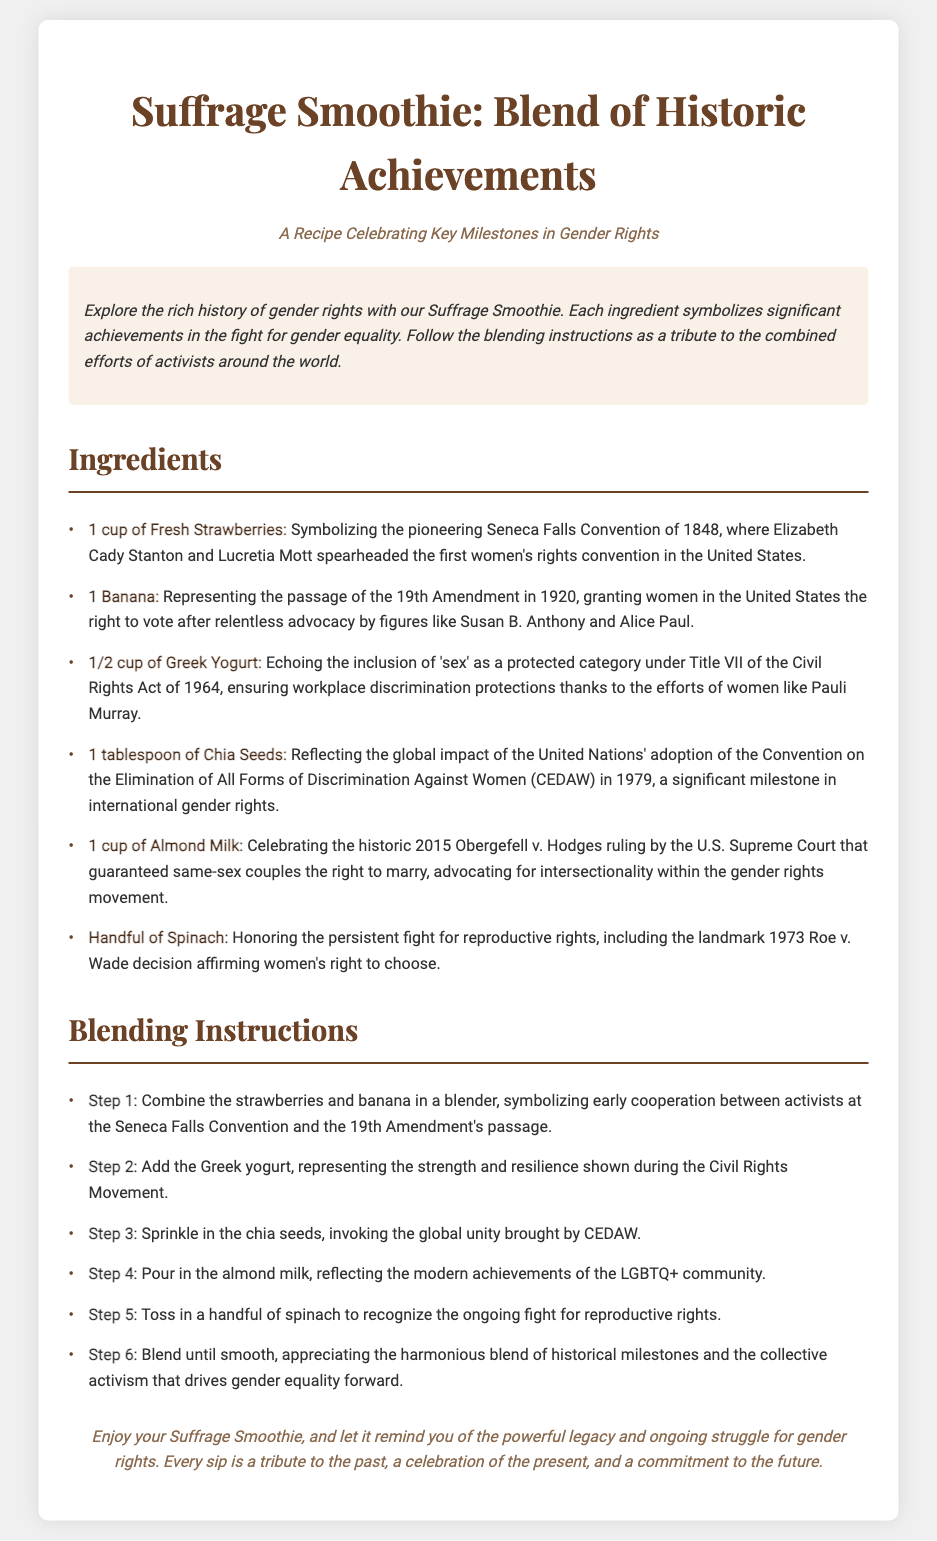What is the main title of the recipe? The main title is prominently displayed at the top of the document, which is "Suffrage Smoothie: Blend of Historic Achievements."
Answer: Suffrage Smoothie: Blend of Historic Achievements How many ingredients are listed in the recipe? The ingredients section details a total of six unique ingredients used in the recipe.
Answer: 6 What does the banana represent in the Suffrage Smoothie? The document indicates that the banana represents the passage of the 19th Amendment in 1920, granting women the right to vote.
Answer: The passage of the 19th Amendment Which year marks the Seneca Falls Convention mentioned in the recipe? The Seneca Falls Convention is identified in the ingredients section as taking place in the year 1848.
Answer: 1848 What is the final step in the blending instructions? The final instruction in the blending section states to blend until smooth, appreciating the harmonious blend of historical milestones and activism.
Answer: Blend until smooth What milestone does the handful of spinach honor? According to the ingredients section, the spinach honors the ongoing fight for reproductive rights, including the Roe v. Wade decision.
Answer: The ongoing fight for reproductive rights 